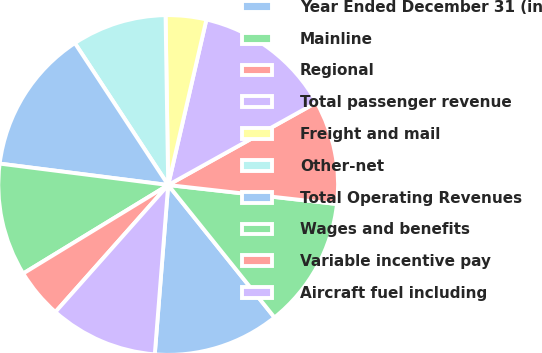Convert chart. <chart><loc_0><loc_0><loc_500><loc_500><pie_chart><fcel>Year Ended December 31 (in<fcel>Mainline<fcel>Regional<fcel>Total passenger revenue<fcel>Freight and mail<fcel>Other-net<fcel>Total Operating Revenues<fcel>Wages and benefits<fcel>Variable incentive pay<fcel>Aircraft fuel including<nl><fcel>12.02%<fcel>12.45%<fcel>9.87%<fcel>13.3%<fcel>3.86%<fcel>9.01%<fcel>13.73%<fcel>10.73%<fcel>4.72%<fcel>10.3%<nl></chart> 